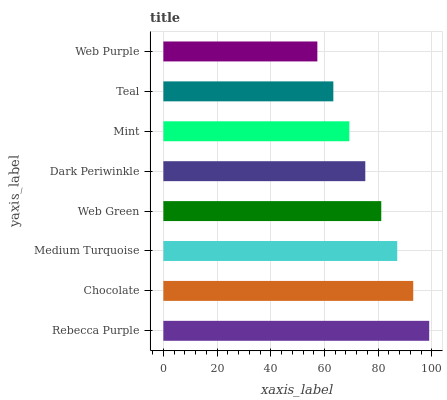Is Web Purple the minimum?
Answer yes or no. Yes. Is Rebecca Purple the maximum?
Answer yes or no. Yes. Is Chocolate the minimum?
Answer yes or no. No. Is Chocolate the maximum?
Answer yes or no. No. Is Rebecca Purple greater than Chocolate?
Answer yes or no. Yes. Is Chocolate less than Rebecca Purple?
Answer yes or no. Yes. Is Chocolate greater than Rebecca Purple?
Answer yes or no. No. Is Rebecca Purple less than Chocolate?
Answer yes or no. No. Is Web Green the high median?
Answer yes or no. Yes. Is Dark Periwinkle the low median?
Answer yes or no. Yes. Is Dark Periwinkle the high median?
Answer yes or no. No. Is Teal the low median?
Answer yes or no. No. 